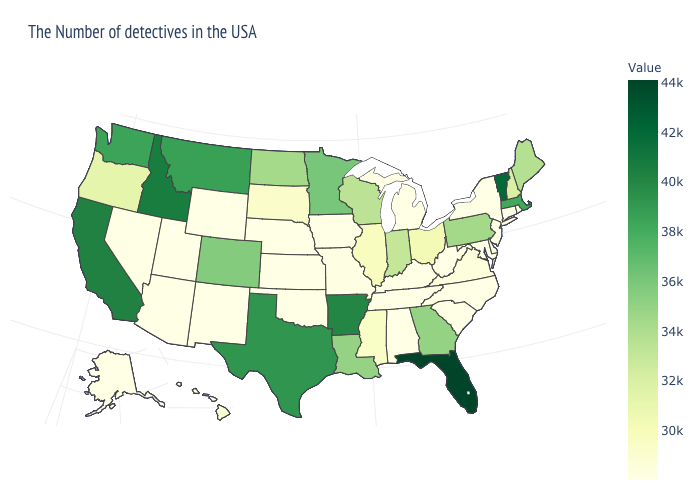Does the map have missing data?
Be succinct. No. Does the map have missing data?
Answer briefly. No. Does the map have missing data?
Keep it brief. No. Which states hav the highest value in the Northeast?
Give a very brief answer. Vermont. 